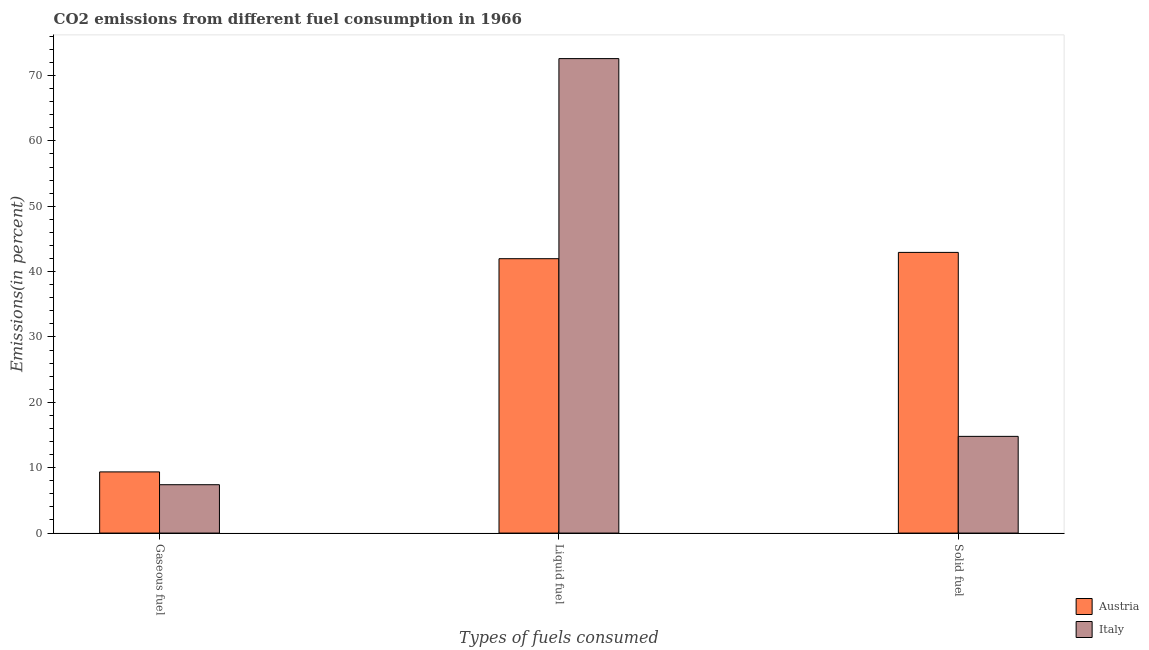How many different coloured bars are there?
Make the answer very short. 2. How many groups of bars are there?
Your answer should be very brief. 3. Are the number of bars per tick equal to the number of legend labels?
Offer a terse response. Yes. How many bars are there on the 1st tick from the right?
Make the answer very short. 2. What is the label of the 2nd group of bars from the left?
Ensure brevity in your answer.  Liquid fuel. What is the percentage of gaseous fuel emission in Austria?
Offer a very short reply. 9.36. Across all countries, what is the maximum percentage of solid fuel emission?
Offer a terse response. 42.94. Across all countries, what is the minimum percentage of liquid fuel emission?
Offer a very short reply. 41.98. In which country was the percentage of liquid fuel emission minimum?
Provide a succinct answer. Austria. What is the total percentage of gaseous fuel emission in the graph?
Provide a succinct answer. 16.76. What is the difference between the percentage of gaseous fuel emission in Italy and that in Austria?
Your answer should be compact. -1.96. What is the difference between the percentage of solid fuel emission in Austria and the percentage of liquid fuel emission in Italy?
Keep it short and to the point. -29.65. What is the average percentage of solid fuel emission per country?
Provide a short and direct response. 28.87. What is the difference between the percentage of gaseous fuel emission and percentage of liquid fuel emission in Italy?
Your answer should be very brief. -65.19. What is the ratio of the percentage of gaseous fuel emission in Italy to that in Austria?
Give a very brief answer. 0.79. Is the difference between the percentage of gaseous fuel emission in Italy and Austria greater than the difference between the percentage of liquid fuel emission in Italy and Austria?
Your response must be concise. No. What is the difference between the highest and the second highest percentage of solid fuel emission?
Provide a short and direct response. 28.14. What is the difference between the highest and the lowest percentage of gaseous fuel emission?
Offer a terse response. 1.96. In how many countries, is the percentage of liquid fuel emission greater than the average percentage of liquid fuel emission taken over all countries?
Keep it short and to the point. 1. Is it the case that in every country, the sum of the percentage of gaseous fuel emission and percentage of liquid fuel emission is greater than the percentage of solid fuel emission?
Your answer should be compact. Yes. How many countries are there in the graph?
Provide a short and direct response. 2. Are the values on the major ticks of Y-axis written in scientific E-notation?
Your answer should be compact. No. Does the graph contain grids?
Provide a short and direct response. No. How are the legend labels stacked?
Provide a succinct answer. Vertical. What is the title of the graph?
Keep it short and to the point. CO2 emissions from different fuel consumption in 1966. Does "Swaziland" appear as one of the legend labels in the graph?
Offer a very short reply. No. What is the label or title of the X-axis?
Ensure brevity in your answer.  Types of fuels consumed. What is the label or title of the Y-axis?
Your answer should be compact. Emissions(in percent). What is the Emissions(in percent) in Austria in Gaseous fuel?
Provide a short and direct response. 9.36. What is the Emissions(in percent) in Italy in Gaseous fuel?
Keep it short and to the point. 7.4. What is the Emissions(in percent) in Austria in Liquid fuel?
Offer a very short reply. 41.98. What is the Emissions(in percent) in Italy in Liquid fuel?
Offer a very short reply. 72.59. What is the Emissions(in percent) in Austria in Solid fuel?
Give a very brief answer. 42.94. What is the Emissions(in percent) in Italy in Solid fuel?
Provide a short and direct response. 14.79. Across all Types of fuels consumed, what is the maximum Emissions(in percent) in Austria?
Keep it short and to the point. 42.94. Across all Types of fuels consumed, what is the maximum Emissions(in percent) in Italy?
Offer a terse response. 72.59. Across all Types of fuels consumed, what is the minimum Emissions(in percent) of Austria?
Your response must be concise. 9.36. Across all Types of fuels consumed, what is the minimum Emissions(in percent) in Italy?
Your answer should be compact. 7.4. What is the total Emissions(in percent) in Austria in the graph?
Your answer should be very brief. 94.27. What is the total Emissions(in percent) of Italy in the graph?
Ensure brevity in your answer.  94.78. What is the difference between the Emissions(in percent) in Austria in Gaseous fuel and that in Liquid fuel?
Give a very brief answer. -32.62. What is the difference between the Emissions(in percent) in Italy in Gaseous fuel and that in Liquid fuel?
Ensure brevity in your answer.  -65.19. What is the difference between the Emissions(in percent) in Austria in Gaseous fuel and that in Solid fuel?
Ensure brevity in your answer.  -33.58. What is the difference between the Emissions(in percent) in Italy in Gaseous fuel and that in Solid fuel?
Your answer should be compact. -7.4. What is the difference between the Emissions(in percent) of Austria in Liquid fuel and that in Solid fuel?
Make the answer very short. -0.96. What is the difference between the Emissions(in percent) of Italy in Liquid fuel and that in Solid fuel?
Your answer should be very brief. 57.79. What is the difference between the Emissions(in percent) in Austria in Gaseous fuel and the Emissions(in percent) in Italy in Liquid fuel?
Your answer should be very brief. -63.23. What is the difference between the Emissions(in percent) in Austria in Gaseous fuel and the Emissions(in percent) in Italy in Solid fuel?
Provide a short and direct response. -5.44. What is the difference between the Emissions(in percent) of Austria in Liquid fuel and the Emissions(in percent) of Italy in Solid fuel?
Provide a short and direct response. 27.18. What is the average Emissions(in percent) of Austria per Types of fuels consumed?
Your answer should be compact. 31.42. What is the average Emissions(in percent) of Italy per Types of fuels consumed?
Your response must be concise. 31.59. What is the difference between the Emissions(in percent) in Austria and Emissions(in percent) in Italy in Gaseous fuel?
Provide a short and direct response. 1.96. What is the difference between the Emissions(in percent) in Austria and Emissions(in percent) in Italy in Liquid fuel?
Provide a short and direct response. -30.61. What is the difference between the Emissions(in percent) of Austria and Emissions(in percent) of Italy in Solid fuel?
Your answer should be very brief. 28.14. What is the ratio of the Emissions(in percent) of Austria in Gaseous fuel to that in Liquid fuel?
Keep it short and to the point. 0.22. What is the ratio of the Emissions(in percent) in Italy in Gaseous fuel to that in Liquid fuel?
Your answer should be very brief. 0.1. What is the ratio of the Emissions(in percent) in Austria in Gaseous fuel to that in Solid fuel?
Keep it short and to the point. 0.22. What is the ratio of the Emissions(in percent) of Italy in Gaseous fuel to that in Solid fuel?
Offer a terse response. 0.5. What is the ratio of the Emissions(in percent) of Austria in Liquid fuel to that in Solid fuel?
Give a very brief answer. 0.98. What is the ratio of the Emissions(in percent) of Italy in Liquid fuel to that in Solid fuel?
Provide a short and direct response. 4.91. What is the difference between the highest and the second highest Emissions(in percent) in Austria?
Offer a terse response. 0.96. What is the difference between the highest and the second highest Emissions(in percent) of Italy?
Your answer should be compact. 57.79. What is the difference between the highest and the lowest Emissions(in percent) of Austria?
Your answer should be very brief. 33.58. What is the difference between the highest and the lowest Emissions(in percent) of Italy?
Provide a short and direct response. 65.19. 